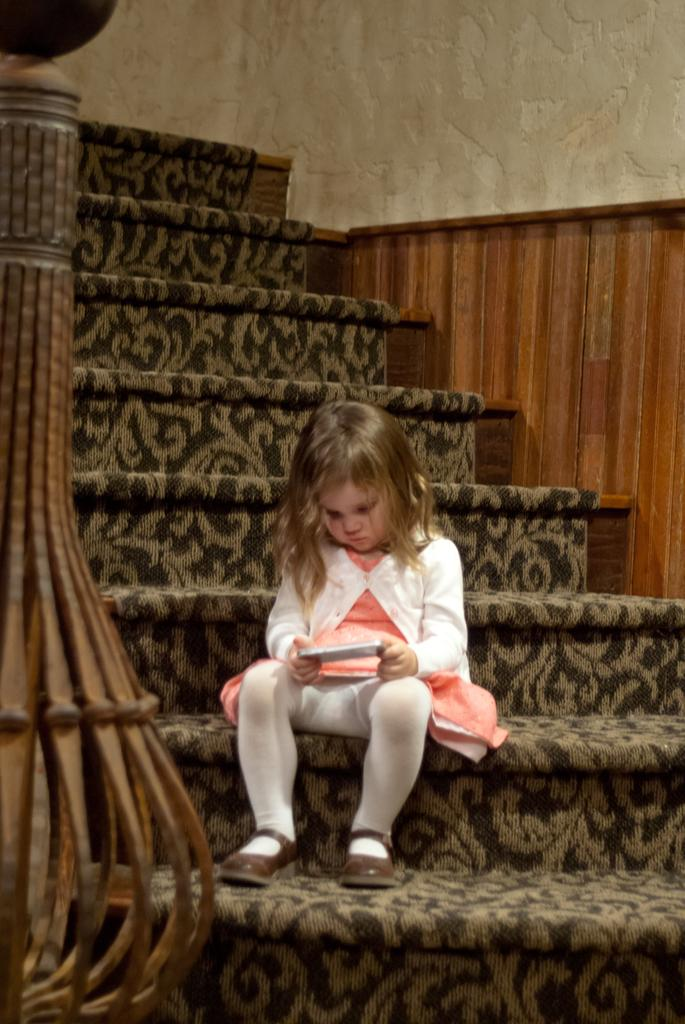What is the girl doing in the image? The girl is sitting in the image. What is the girl holding in the image? The girl is holding an object. What can be seen in the background of the image? There is a wall in the image, and there are steps in the image. Is the girl eating a hot banana in the image? There is no banana present in the image, and no indication of the girl eating anything. Additionally, the temperature of the food is not mentioned in the provided facts. 